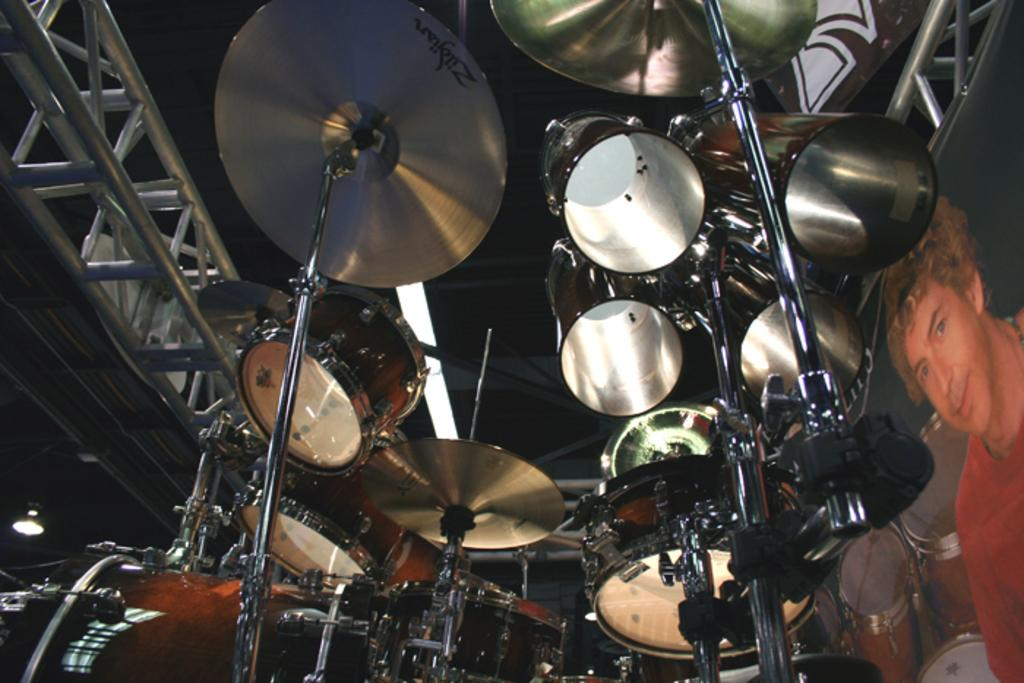What type of musical instruments are present in the image? There are drums in the image, which are a type of musical instrument. What other objects can be seen in the image? There are metal rods and lights visible in the image. What can be inferred about the purpose of the metal rods in the image? The metal rods may be used as part of a musical setup or as a support structure for the lights. Is there a lawyer present in the image? No, there is no lawyer present in the image. Can you join the drums and lights together in the image? The drums and lights are separate objects in the image and cannot be joined together. 